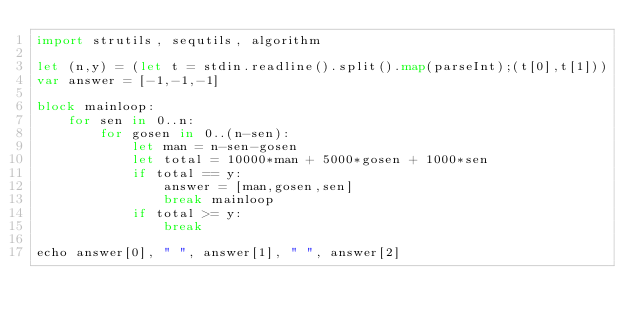Convert code to text. <code><loc_0><loc_0><loc_500><loc_500><_Nim_>import strutils, sequtils, algorithm

let (n,y) = (let t = stdin.readline().split().map(parseInt);(t[0],t[1]))
var answer = [-1,-1,-1]

block mainloop:
    for sen in 0..n:
        for gosen in 0..(n-sen):
            let man = n-sen-gosen
            let total = 10000*man + 5000*gosen + 1000*sen 
            if total == y:
                answer = [man,gosen,sen]               
                break mainloop
            if total >= y:
                break

echo answer[0], " ", answer[1], " ", answer[2]</code> 